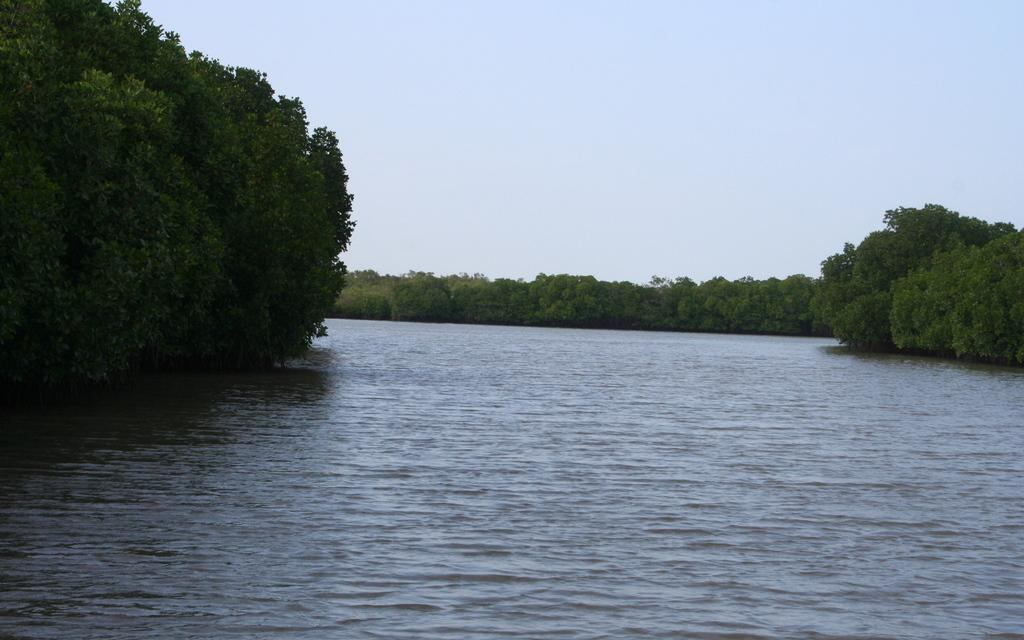What type of natural feature is present in the image? There is a river in the image. What surrounds the river in the image? There are trees on both sides of the river. What is the condition of the sky in the image? The sky is clear in the image. How many dogs are playing with the fire in the image? There are no dogs or fire present in the image. What angle is the river flowing at in the image? The angle of the river's flow cannot be determined from the image, as it is not mentioned in the provided facts. 